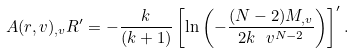Convert formula to latex. <formula><loc_0><loc_0><loc_500><loc_500>A ( r , v ) _ { , v } R ^ { \prime } = - \frac { k } { ( k + 1 ) } \left [ \ln \left ( - \frac { ( N - 2 ) { M } _ { , v } } { 2 k \ v ^ { N - 2 } } \right ) \right ] ^ { \prime } .</formula> 